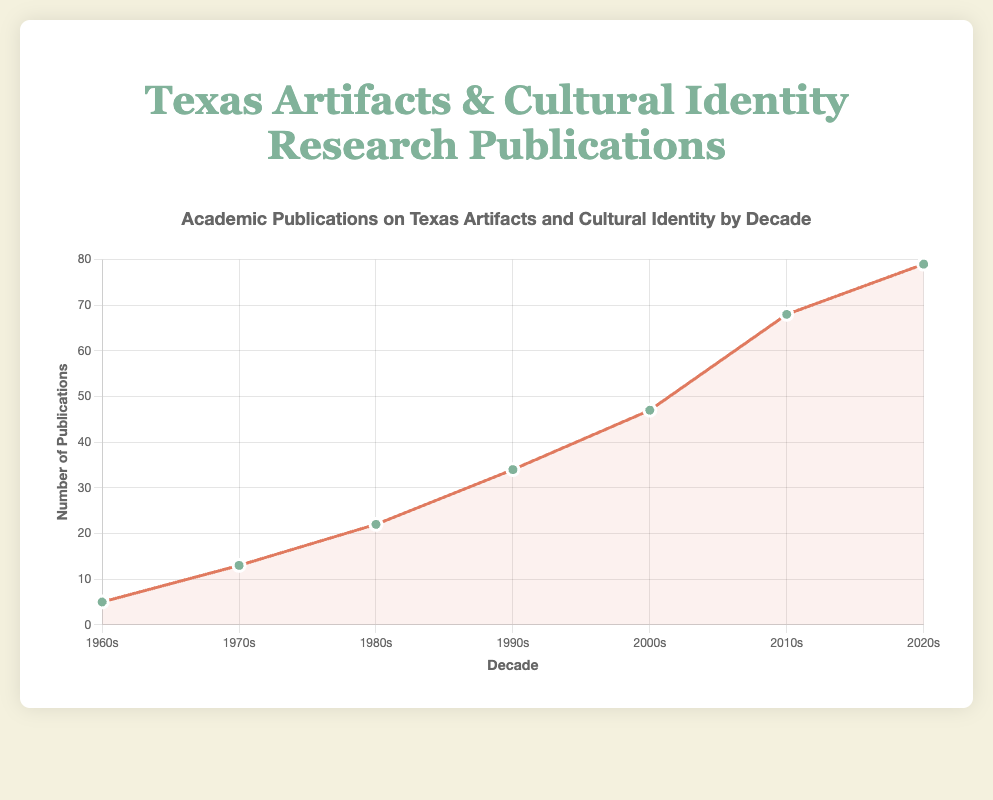What's the decade with the highest number of academic publications? To find the highest number of publications, look at the peaks on the line plot. The highest point corresponds to the 2020s with 79 publications.
Answer: 2020s What's the total number of academic publications between the 1960s and 1980s? Sum the number of publications for the decades 1960s, 1970s, and 1980s. This gives 5 (1960s) + 13 (1970s) + 22 (1980s) = 40.
Answer: 40 How does the number of publications in the 1990s compare to that in the 2000s? Compare the heights of the points for the 1990s and 2000s. The 1990s have 34 publications, and the 2000s have 47 publications. Therefore, the 2000s have 13 more publications than the 1990s.
Answer: 13 more What's the decade with the lowest number of academic publications? Find the lowest point on the line plot. The lowest point corresponds to the 1960s with 5 publications.
Answer: 1960s What is the difference in publications between the 1980s and the 2010s? Subtract the number of publications in the 1980s from those in the 2010s. This gives 68 (2010s) - 22 (1980s) = 46.
Answer: 46 What trend do you notice in the number of academic publications across the decades? Observe the overall shape of the line plot. The trend shows a consistent increase in the number of academic publications from the 1960s to the 2020s.
Answer: Increasing trend Between which consecutive decades is the largest increase in publications observed? Look for the sharpest upward slope between consecutive points. The largest increase is between the 2010s (68 publications) and the 2020s (79 publications), an increase of 11.
Answer: Between 2010s and 2020s How many decades had fewer than 30 publications? Identify the points on the line plot below 30 publications. The decades are 1960s (5), 1970s (13), and 1980s (22). This gives 3 decades.
Answer: 3 What was the average number of publications per decade from the 1980s to the 2020s? Sum the publications from the 1980s to the 2020s and divide by the number of decades (4). Sum = 22 (1980s) + 34 (1990s) + 47 (2000s) + 68 (2010s) + 79 (2020s) = 250. Average = 250/5 = 50.
Answer: 50 